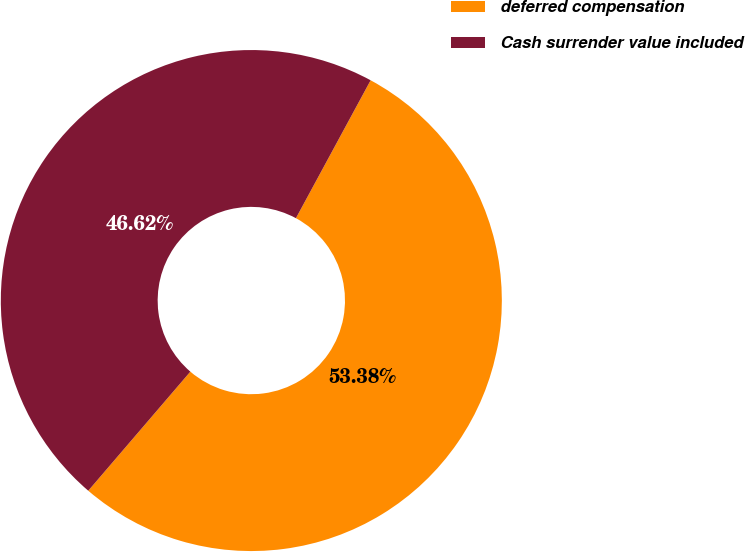<chart> <loc_0><loc_0><loc_500><loc_500><pie_chart><fcel>deferred compensation<fcel>Cash surrender value included<nl><fcel>53.38%<fcel>46.62%<nl></chart> 